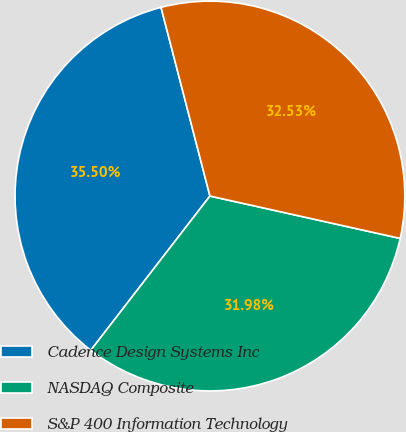Convert chart. <chart><loc_0><loc_0><loc_500><loc_500><pie_chart><fcel>Cadence Design Systems Inc<fcel>NASDAQ Composite<fcel>S&P 400 Information Technology<nl><fcel>35.5%<fcel>31.98%<fcel>32.53%<nl></chart> 